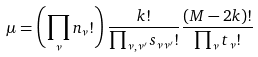Convert formula to latex. <formula><loc_0><loc_0><loc_500><loc_500>\mu = \left ( \prod _ { \nu } n _ { \nu } ! \right ) \frac { k ! } { \prod _ { \nu , \nu ^ { \prime } } s _ { \nu \nu ^ { \prime } } ! } \frac { ( M - 2 k ) ! } { \prod _ { \nu } t _ { \nu } ! }</formula> 